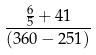Convert formula to latex. <formula><loc_0><loc_0><loc_500><loc_500>\frac { \frac { 6 } { 5 } + 4 1 } { ( 3 6 0 - 2 5 1 ) }</formula> 